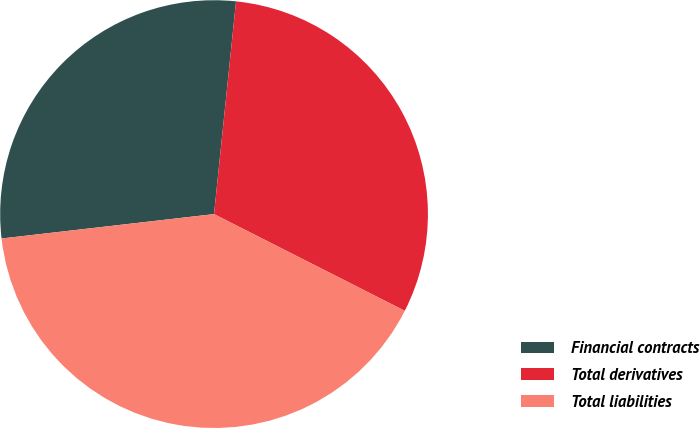<chart> <loc_0><loc_0><loc_500><loc_500><pie_chart><fcel>Financial contracts<fcel>Total derivatives<fcel>Total liabilities<nl><fcel>28.46%<fcel>30.83%<fcel>40.71%<nl></chart> 